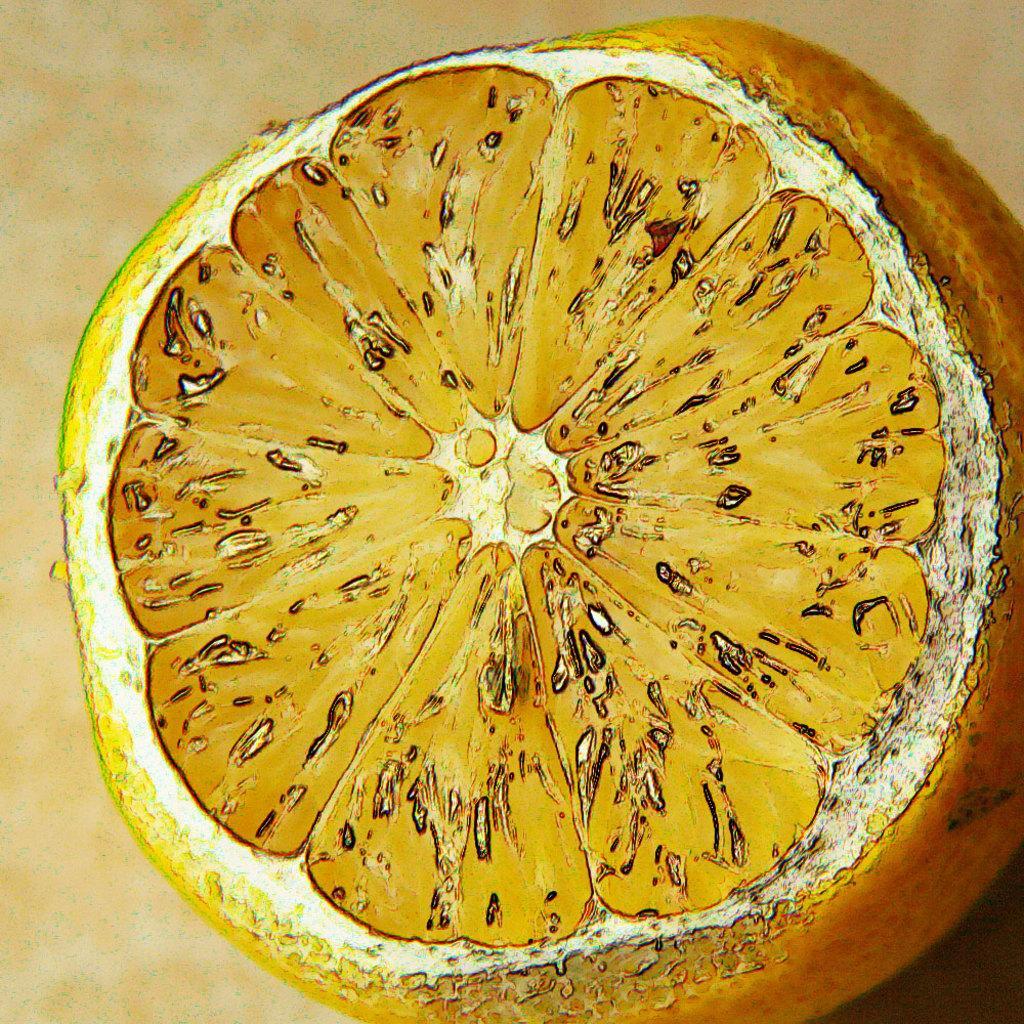How would you summarize this image in a sentence or two? In the image in the center, we can see the painting of the orange fruit. 